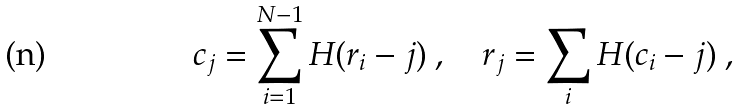<formula> <loc_0><loc_0><loc_500><loc_500>c _ { j } = \sum _ { i = 1 } ^ { N - 1 } H ( r _ { i } - j ) \ , \quad r _ { j } = \sum _ { i } H ( c _ { i } - j ) \ ,</formula> 